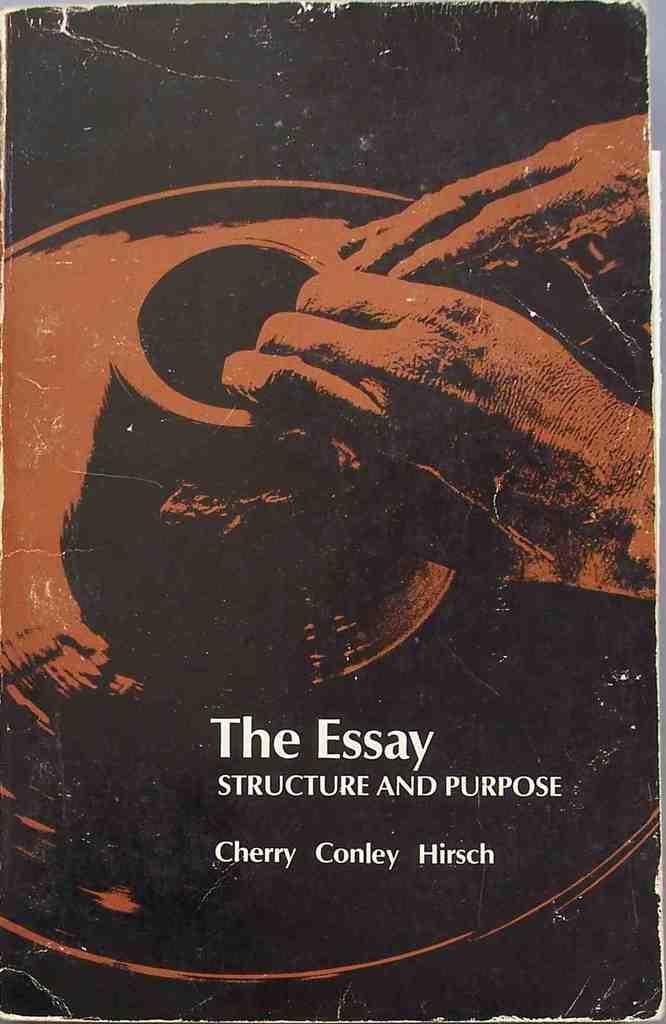What is the title?
Give a very brief answer. The essay. Who is the author?
Ensure brevity in your answer.  Cherry conley hirsch. 